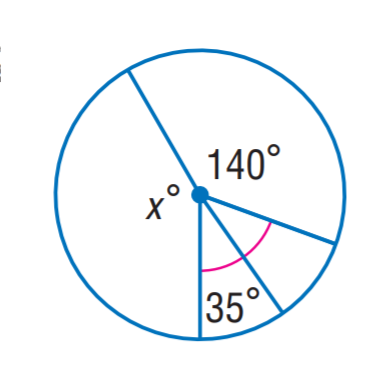Question: Find x.
Choices:
A. 70
B. 110
C. 140
D. 150
Answer with the letter. Answer: D 